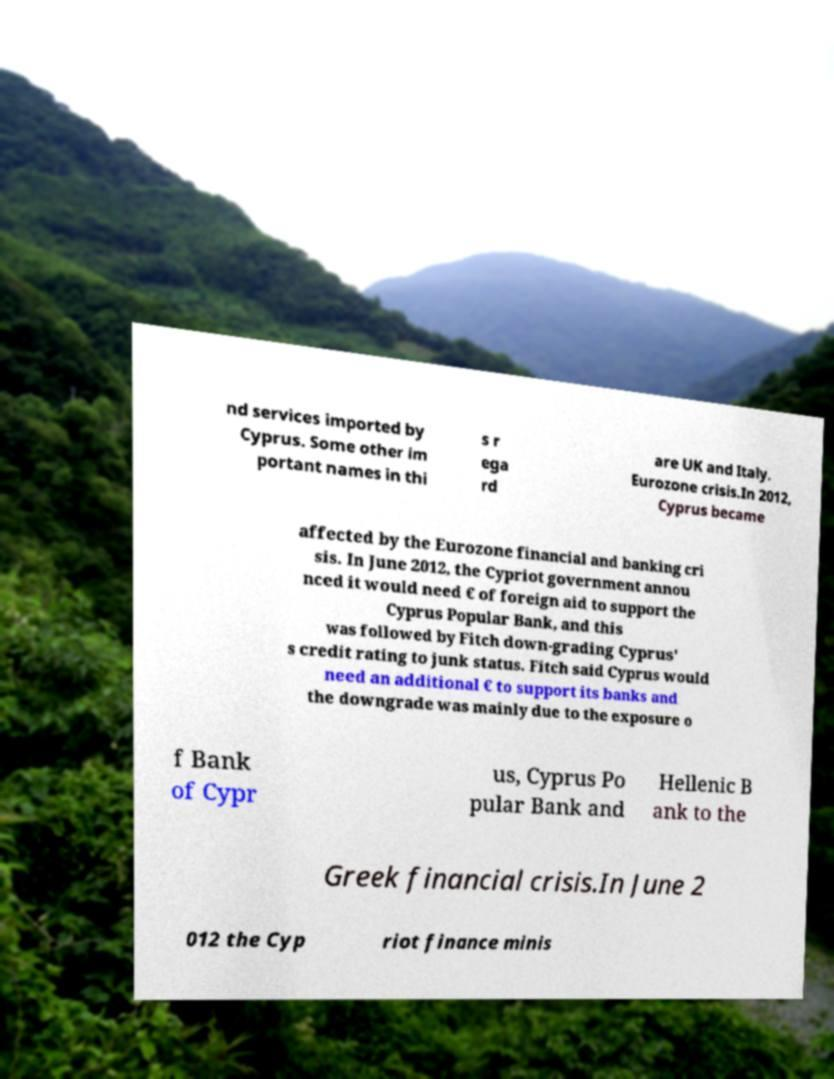For documentation purposes, I need the text within this image transcribed. Could you provide that? nd services imported by Cyprus. Some other im portant names in thi s r ega rd are UK and Italy. Eurozone crisis.In 2012, Cyprus became affected by the Eurozone financial and banking cri sis. In June 2012, the Cypriot government annou nced it would need € of foreign aid to support the Cyprus Popular Bank, and this was followed by Fitch down-grading Cyprus' s credit rating to junk status. Fitch said Cyprus would need an additional € to support its banks and the downgrade was mainly due to the exposure o f Bank of Cypr us, Cyprus Po pular Bank and Hellenic B ank to the Greek financial crisis.In June 2 012 the Cyp riot finance minis 